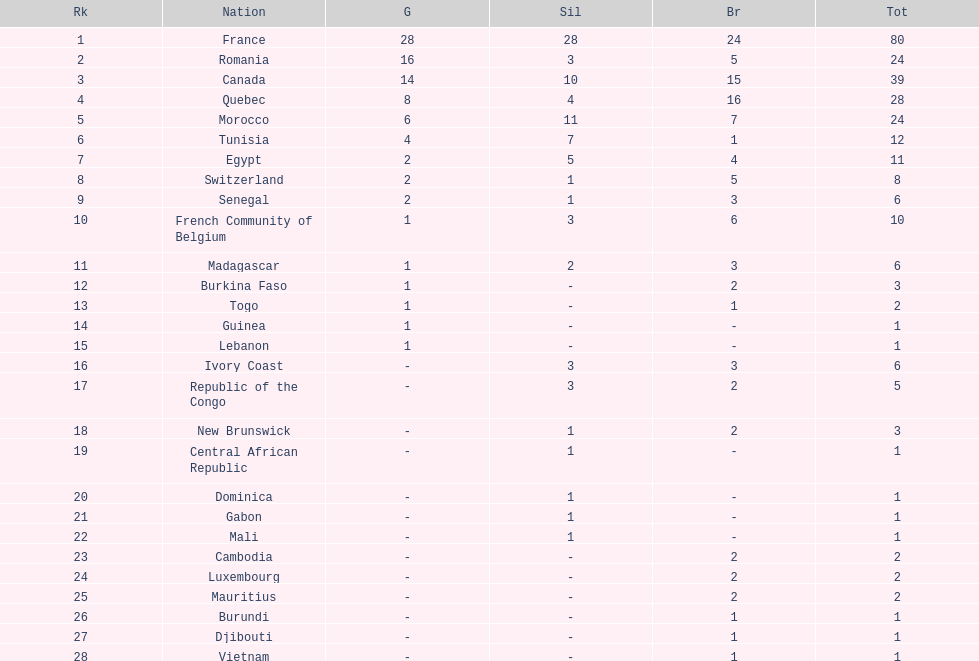Who placed in first according to medals? France. Can you give me this table as a dict? {'header': ['Rk', 'Nation', 'G', 'Sil', 'Br', 'Tot'], 'rows': [['1', 'France', '28', '28', '24', '80'], ['2', 'Romania', '16', '3', '5', '24'], ['3', 'Canada', '14', '10', '15', '39'], ['4', 'Quebec', '8', '4', '16', '28'], ['5', 'Morocco', '6', '11', '7', '24'], ['6', 'Tunisia', '4', '7', '1', '12'], ['7', 'Egypt', '2', '5', '4', '11'], ['8', 'Switzerland', '2', '1', '5', '8'], ['9', 'Senegal', '2', '1', '3', '6'], ['10', 'French Community of Belgium', '1', '3', '6', '10'], ['11', 'Madagascar', '1', '2', '3', '6'], ['12', 'Burkina Faso', '1', '-', '2', '3'], ['13', 'Togo', '1', '-', '1', '2'], ['14', 'Guinea', '1', '-', '-', '1'], ['15', 'Lebanon', '1', '-', '-', '1'], ['16', 'Ivory Coast', '-', '3', '3', '6'], ['17', 'Republic of the Congo', '-', '3', '2', '5'], ['18', 'New Brunswick', '-', '1', '2', '3'], ['19', 'Central African Republic', '-', '1', '-', '1'], ['20', 'Dominica', '-', '1', '-', '1'], ['21', 'Gabon', '-', '1', '-', '1'], ['22', 'Mali', '-', '1', '-', '1'], ['23', 'Cambodia', '-', '-', '2', '2'], ['24', 'Luxembourg', '-', '-', '2', '2'], ['25', 'Mauritius', '-', '-', '2', '2'], ['26', 'Burundi', '-', '-', '1', '1'], ['27', 'Djibouti', '-', '-', '1', '1'], ['28', 'Vietnam', '-', '-', '1', '1']]} 